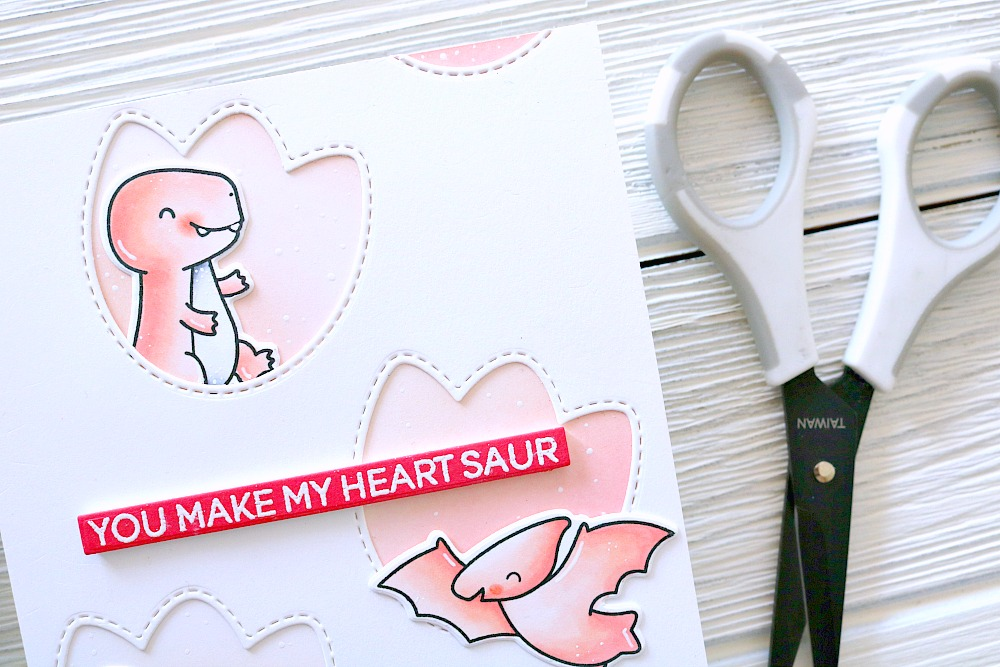How could the color palette of this card influence the recipient’s emotions? The color palette on this card features soft pinks and vibrant reds, which are often associated with warmth, affection, and love. The gentle contrast between the playful pink tones and the bold red text 'YOU MAKE MY HEART SAUR' elicits feelings of joy and playfulness. This thoughtful use of colors can make the recipient feel cherished and bring a smile, emphasizing the card’s heartfelt message through visual means. 